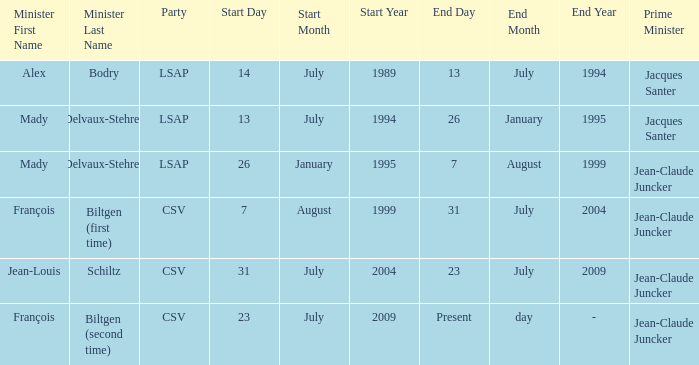Who was the minister for the CSV party with a present day end date? François Biltgen (second time). 